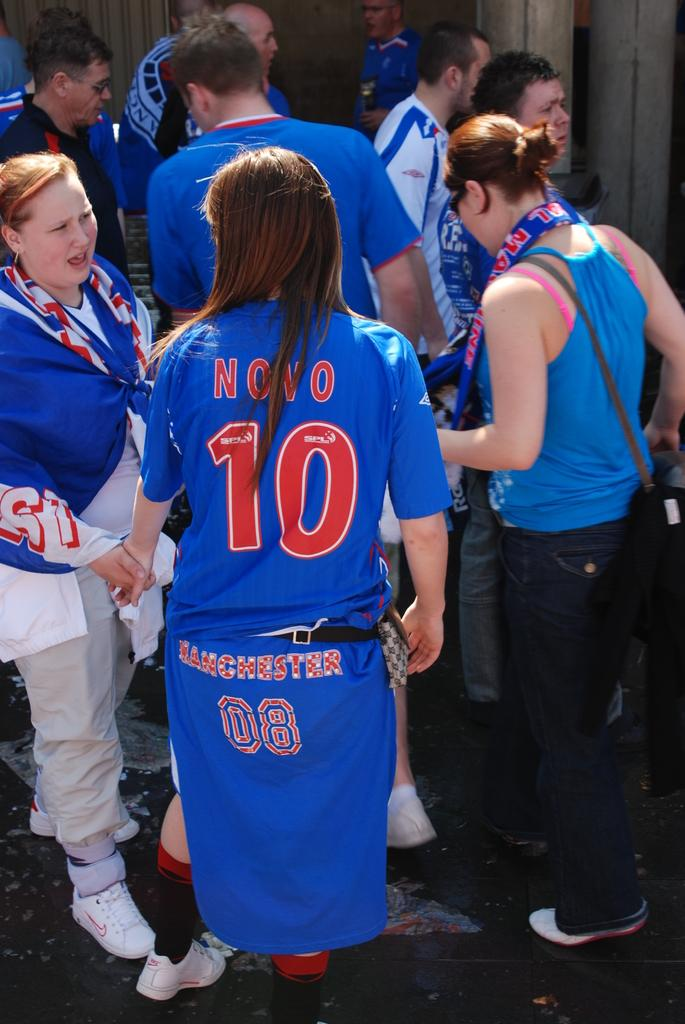Provide a one-sentence caption for the provided image. The back of a woman wearing a blue shirt with the words Novo and the number 10. 